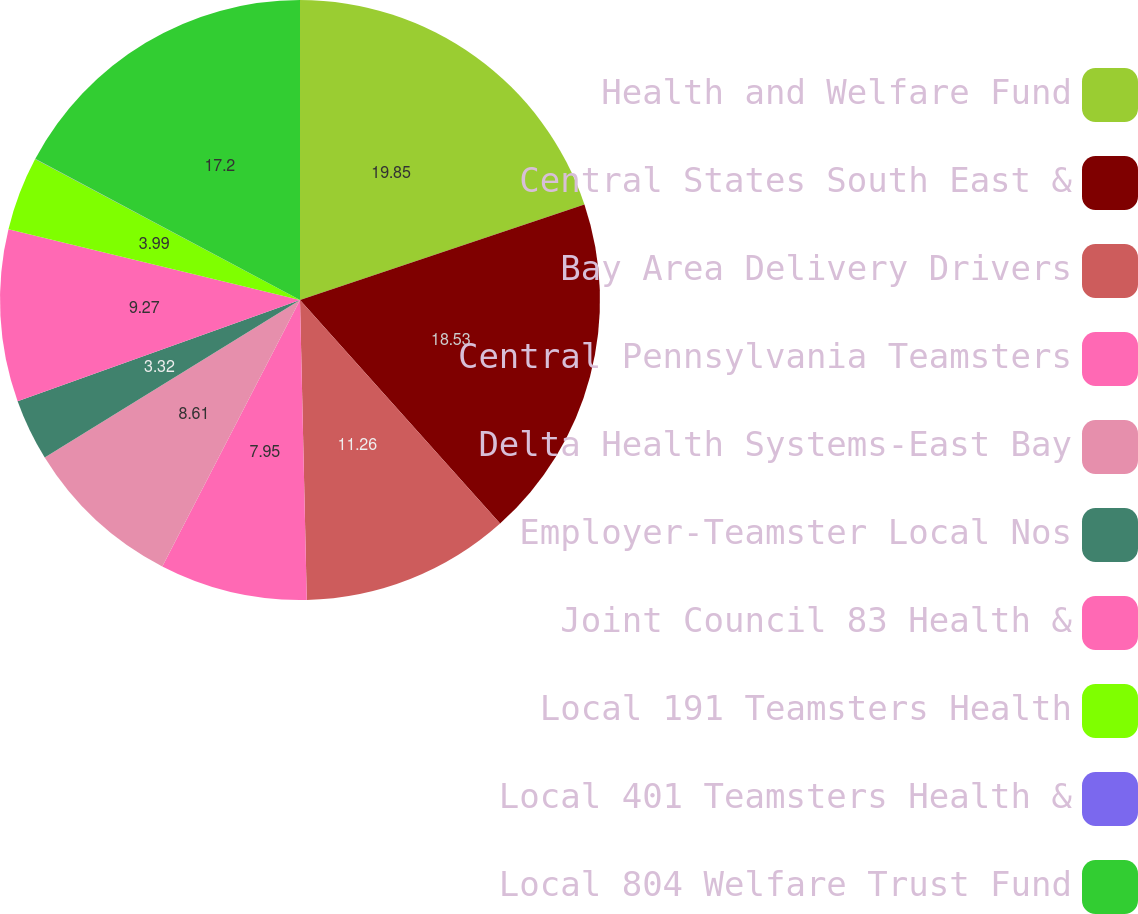<chart> <loc_0><loc_0><loc_500><loc_500><pie_chart><fcel>Health and Welfare Fund<fcel>Central States South East &<fcel>Bay Area Delivery Drivers<fcel>Central Pennsylvania Teamsters<fcel>Delta Health Systems-East Bay<fcel>Employer-Teamster Local Nos<fcel>Joint Council 83 Health &<fcel>Local 191 Teamsters Health<fcel>Local 401 Teamsters Health &<fcel>Local 804 Welfare Trust Fund<nl><fcel>19.85%<fcel>18.53%<fcel>11.26%<fcel>7.95%<fcel>8.61%<fcel>3.32%<fcel>9.27%<fcel>3.99%<fcel>0.02%<fcel>17.2%<nl></chart> 